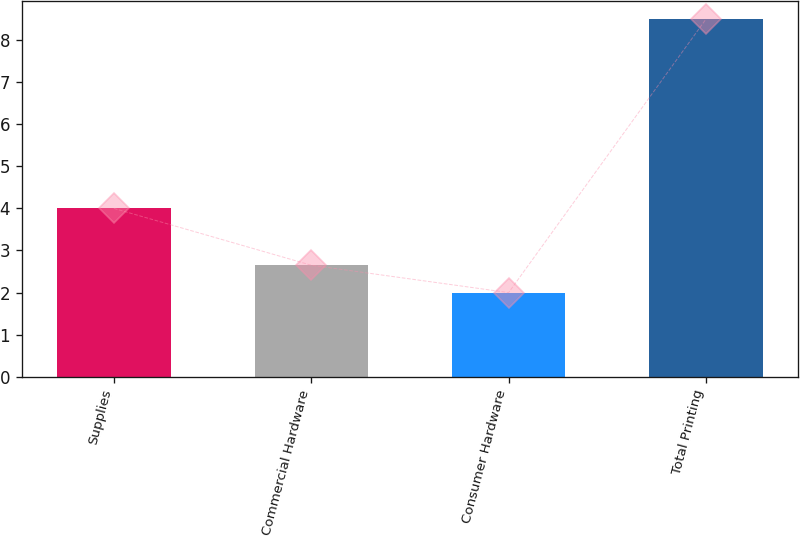Convert chart. <chart><loc_0><loc_0><loc_500><loc_500><bar_chart><fcel>Supplies<fcel>Commercial Hardware<fcel>Consumer Hardware<fcel>Total Printing<nl><fcel>4<fcel>2.65<fcel>2<fcel>8.5<nl></chart> 